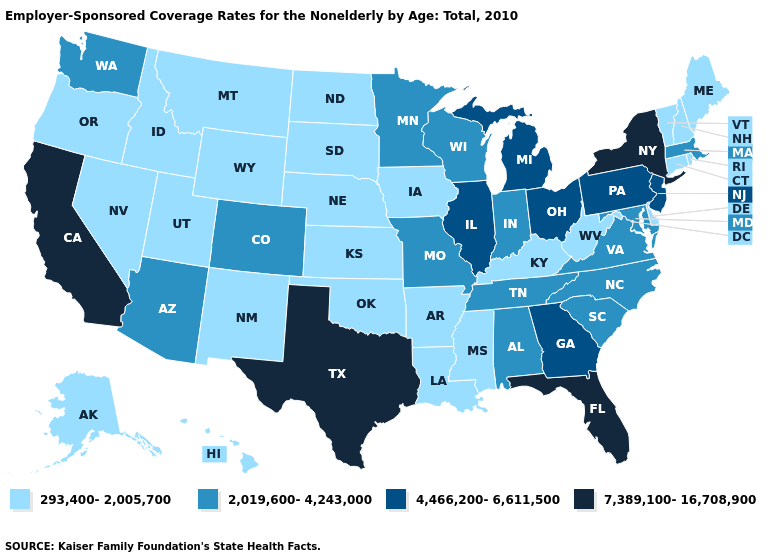Name the states that have a value in the range 4,466,200-6,611,500?
Write a very short answer. Georgia, Illinois, Michigan, New Jersey, Ohio, Pennsylvania. Among the states that border Oklahoma , does Colorado have the highest value?
Concise answer only. No. Name the states that have a value in the range 293,400-2,005,700?
Write a very short answer. Alaska, Arkansas, Connecticut, Delaware, Hawaii, Idaho, Iowa, Kansas, Kentucky, Louisiana, Maine, Mississippi, Montana, Nebraska, Nevada, New Hampshire, New Mexico, North Dakota, Oklahoma, Oregon, Rhode Island, South Dakota, Utah, Vermont, West Virginia, Wyoming. What is the value of Indiana?
Keep it brief. 2,019,600-4,243,000. Name the states that have a value in the range 2,019,600-4,243,000?
Short answer required. Alabama, Arizona, Colorado, Indiana, Maryland, Massachusetts, Minnesota, Missouri, North Carolina, South Carolina, Tennessee, Virginia, Washington, Wisconsin. Among the states that border Illinois , which have the lowest value?
Quick response, please. Iowa, Kentucky. Name the states that have a value in the range 2,019,600-4,243,000?
Write a very short answer. Alabama, Arizona, Colorado, Indiana, Maryland, Massachusetts, Minnesota, Missouri, North Carolina, South Carolina, Tennessee, Virginia, Washington, Wisconsin. Among the states that border New Mexico , does Texas have the highest value?
Give a very brief answer. Yes. Name the states that have a value in the range 293,400-2,005,700?
Write a very short answer. Alaska, Arkansas, Connecticut, Delaware, Hawaii, Idaho, Iowa, Kansas, Kentucky, Louisiana, Maine, Mississippi, Montana, Nebraska, Nevada, New Hampshire, New Mexico, North Dakota, Oklahoma, Oregon, Rhode Island, South Dakota, Utah, Vermont, West Virginia, Wyoming. How many symbols are there in the legend?
Quick response, please. 4. Name the states that have a value in the range 293,400-2,005,700?
Quick response, please. Alaska, Arkansas, Connecticut, Delaware, Hawaii, Idaho, Iowa, Kansas, Kentucky, Louisiana, Maine, Mississippi, Montana, Nebraska, Nevada, New Hampshire, New Mexico, North Dakota, Oklahoma, Oregon, Rhode Island, South Dakota, Utah, Vermont, West Virginia, Wyoming. Does Vermont have the lowest value in the Northeast?
Quick response, please. Yes. What is the value of Oregon?
Quick response, please. 293,400-2,005,700. What is the lowest value in the MidWest?
Keep it brief. 293,400-2,005,700. Name the states that have a value in the range 7,389,100-16,708,900?
Give a very brief answer. California, Florida, New York, Texas. 